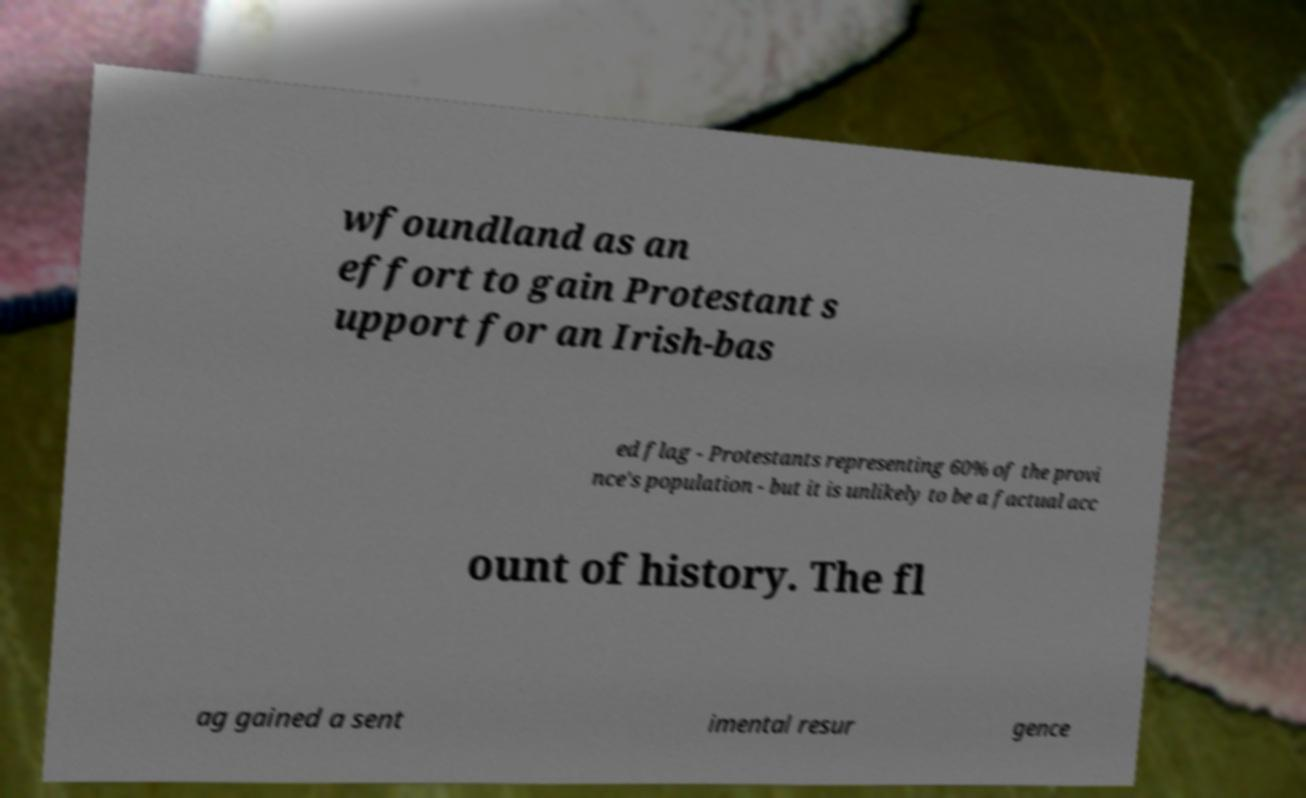Can you read and provide the text displayed in the image?This photo seems to have some interesting text. Can you extract and type it out for me? wfoundland as an effort to gain Protestant s upport for an Irish-bas ed flag - Protestants representing 60% of the provi nce's population - but it is unlikely to be a factual acc ount of history. The fl ag gained a sent imental resur gence 